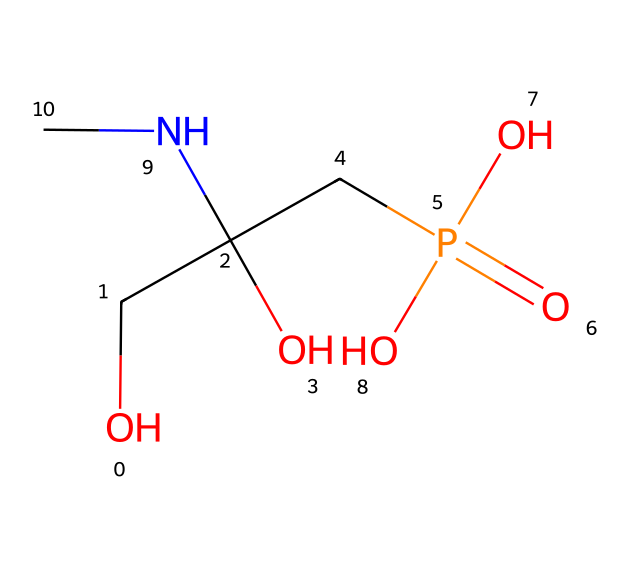What is the molecular formula of glyphosate? The SMILES representation indicates the different elements present in glyphosate. Counting the carbon (C), hydrogen (H), nitrogen (N), oxygen (O), and phosphorus (P) atoms gives the molecular formula C3H8N5O5P.
Answer: C3H8N5O5P How many hydroxyl groups are present in glyphosate? The structural representation reveals two -OH groups (hydroxyl groups) in glyphosate, observable from the presence of oxygen atoms bonded to hydrogen.
Answer: 2 What is the role of the nitrogen atom in glyphosate? The nitrogen atom in glyphosate is part of the amine functional group, which is often involved in biological activity and the herbicidal action of the chemical.
Answer: amine How many total atoms are there in glyphosate? By counting each unique atom represented in the SMILES notation: 3 carbon, 8 hydrogen, 1 nitrogen, 5 oxygen, and 1 phosphorus totals to 18 atoms.
Answer: 18 What type of chemical reaction does glyphosate primarily undergo? Glyphosate primarily undergoes enzymatic reactions associated with amino acid synthesis inhibition, characteristic of its herbicide action against plants.
Answer: enzymatic reaction Is glyphosate water-soluble? The presence of multiple hydroxyl and phosphate groups in the structure typically indicates that glyphosate is hydrophilic, hence it is water-soluble.
Answer: yes 